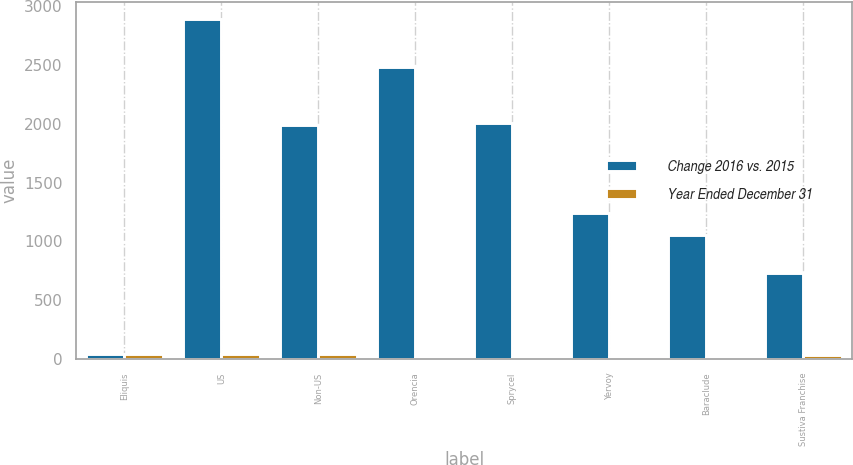<chart> <loc_0><loc_0><loc_500><loc_500><stacked_bar_chart><ecel><fcel>Eliquis<fcel>US<fcel>Non-US<fcel>Orencia<fcel>Sprycel<fcel>Yervoy<fcel>Baraclude<fcel>Sustiva Franchise<nl><fcel>Change 2016 vs. 2015<fcel>47<fcel>2887<fcel>1985<fcel>2479<fcel>2005<fcel>1244<fcel>1052<fcel>729<nl><fcel>Year Ended December 31<fcel>46<fcel>47<fcel>44<fcel>9<fcel>10<fcel>18<fcel>12<fcel>32<nl></chart> 